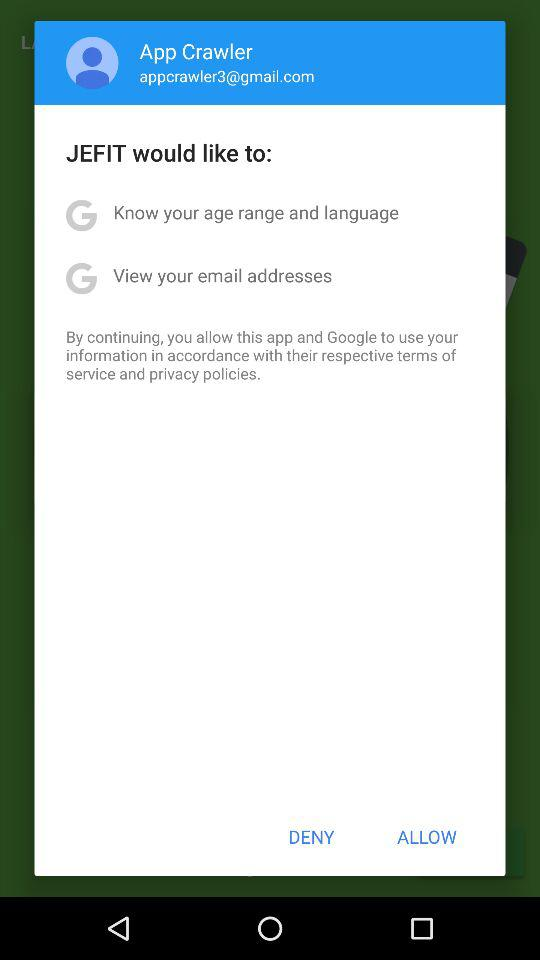What is the name of the user? The name of the user is App Crawler. 